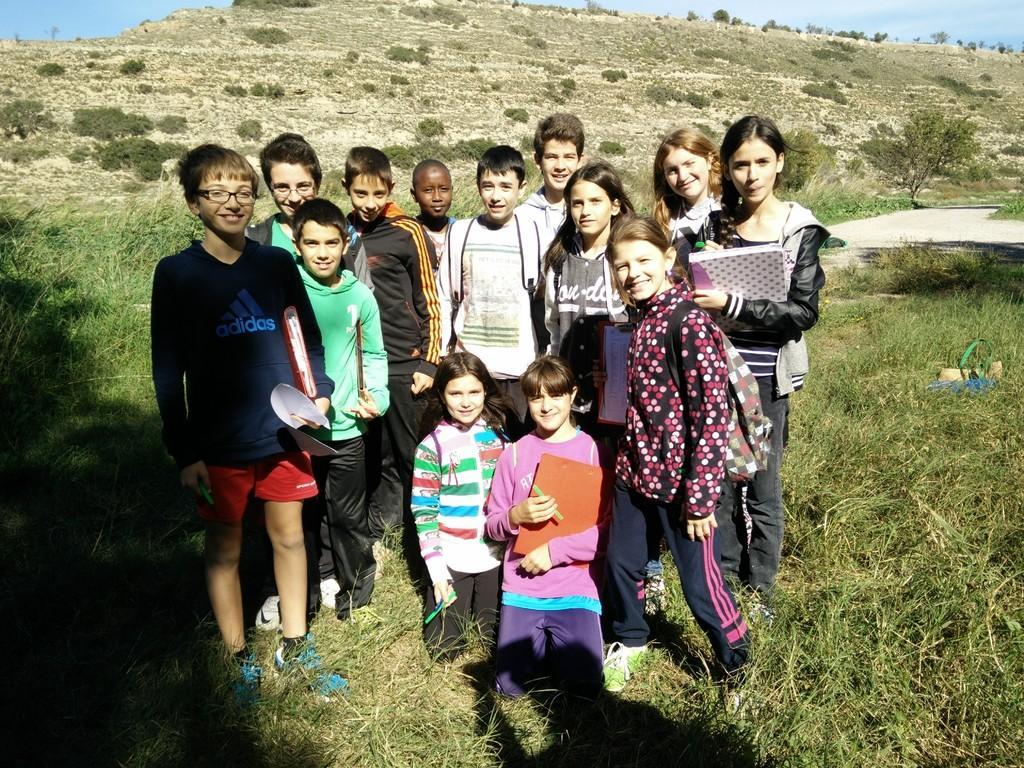Can you describe this image briefly? In this image there are a few people standing and few are sitting on the surface of the grass with a smile on their face. In the background there are few trees and the sky. 